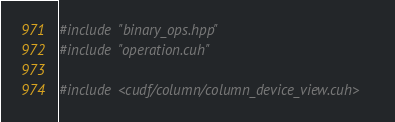Convert code to text. <code><loc_0><loc_0><loc_500><loc_500><_Cuda_>
#include "binary_ops.hpp"
#include "operation.cuh"

#include <cudf/column/column_device_view.cuh></code> 